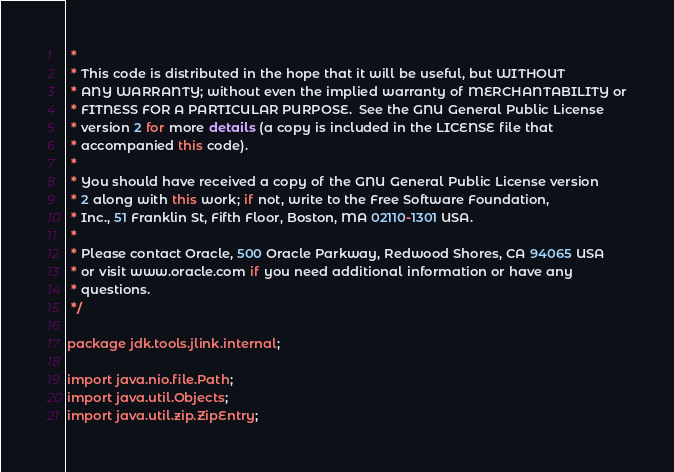<code> <loc_0><loc_0><loc_500><loc_500><_Java_> *
 * This code is distributed in the hope that it will be useful, but WITHOUT
 * ANY WARRANTY; without even the implied warranty of MERCHANTABILITY or
 * FITNESS FOR A PARTICULAR PURPOSE.  See the GNU General Public License
 * version 2 for more details (a copy is included in the LICENSE file that
 * accompanied this code).
 *
 * You should have received a copy of the GNU General Public License version
 * 2 along with this work; if not, write to the Free Software Foundation,
 * Inc., 51 Franklin St, Fifth Floor, Boston, MA 02110-1301 USA.
 *
 * Please contact Oracle, 500 Oracle Parkway, Redwood Shores, CA 94065 USA
 * or visit www.oracle.com if you need additional information or have any
 * questions.
 */

package jdk.tools.jlink.internal;

import java.nio.file.Path;
import java.util.Objects;
import java.util.zip.ZipEntry;
</code> 